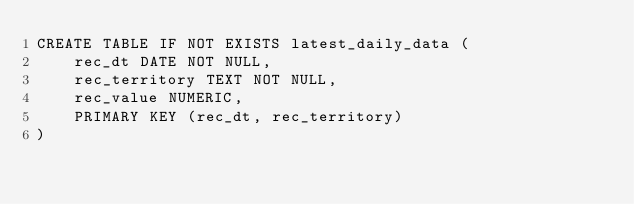Convert code to text. <code><loc_0><loc_0><loc_500><loc_500><_SQL_>CREATE TABLE IF NOT EXISTS latest_daily_data (
    rec_dt DATE NOT NULL,
    rec_territory TEXT NOT NULL,
    rec_value NUMERIC,
    PRIMARY KEY (rec_dt, rec_territory)
)
</code> 